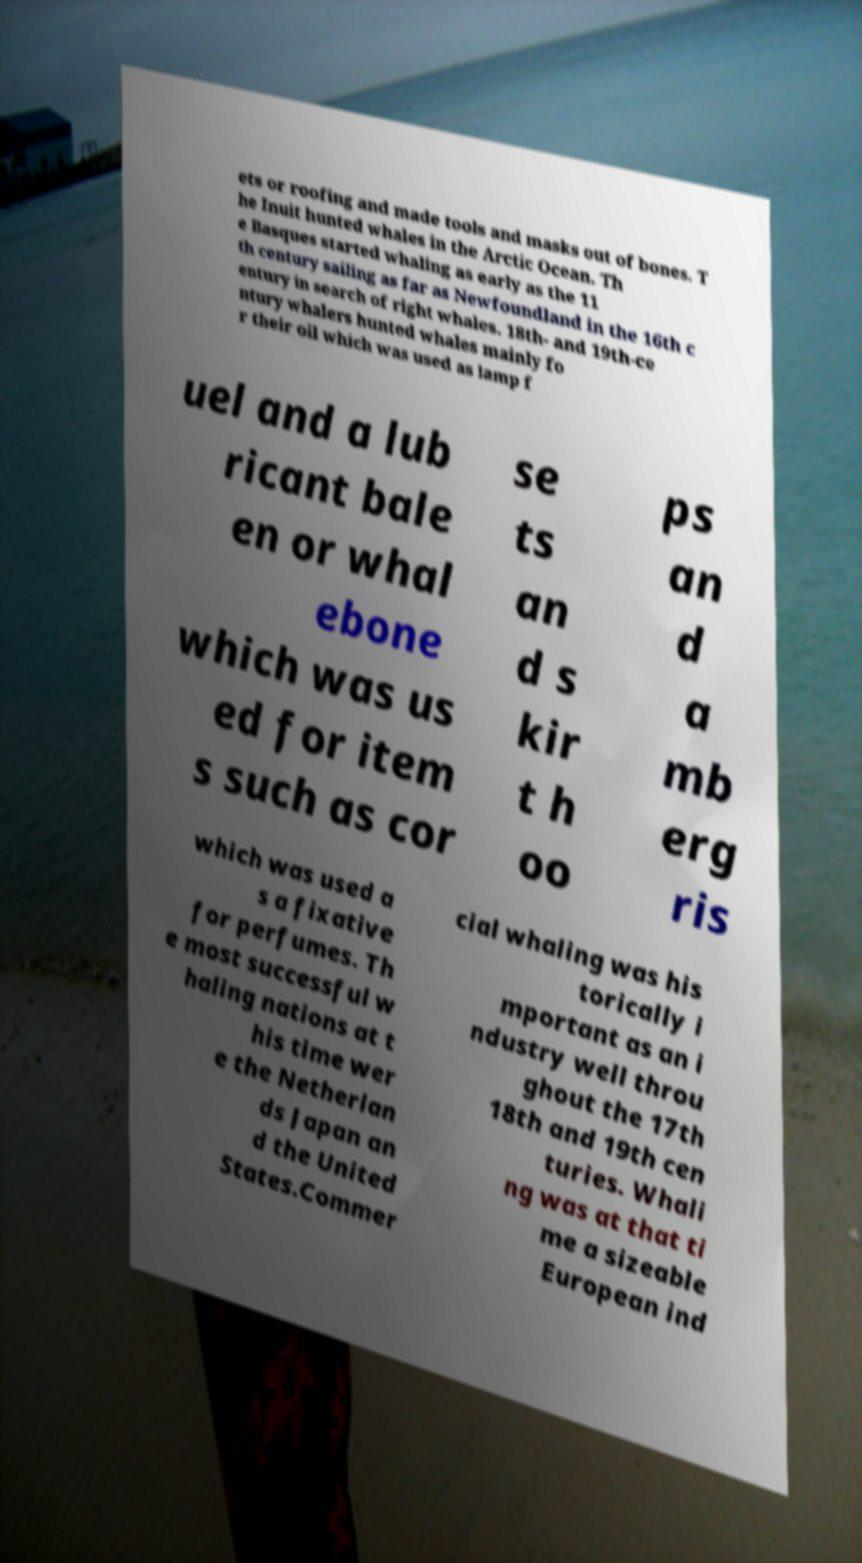Could you extract and type out the text from this image? ets or roofing and made tools and masks out of bones. T he Inuit hunted whales in the Arctic Ocean. Th e Basques started whaling as early as the 11 th century sailing as far as Newfoundland in the 16th c entury in search of right whales. 18th- and 19th-ce ntury whalers hunted whales mainly fo r their oil which was used as lamp f uel and a lub ricant bale en or whal ebone which was us ed for item s such as cor se ts an d s kir t h oo ps an d a mb erg ris which was used a s a fixative for perfumes. Th e most successful w haling nations at t his time wer e the Netherlan ds Japan an d the United States.Commer cial whaling was his torically i mportant as an i ndustry well throu ghout the 17th 18th and 19th cen turies. Whali ng was at that ti me a sizeable European ind 